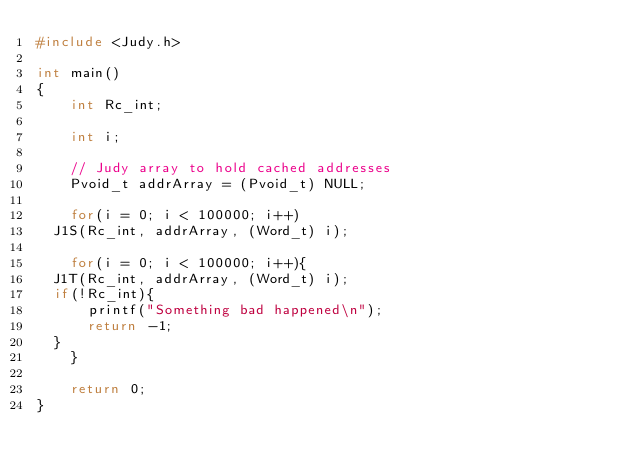<code> <loc_0><loc_0><loc_500><loc_500><_C_>#include <Judy.h>

int main()
{
    int Rc_int;

    int i;

    // Judy array to hold cached addresses
    Pvoid_t addrArray = (Pvoid_t) NULL;

    for(i = 0; i < 100000; i++)
	J1S(Rc_int, addrArray, (Word_t) i);

    for(i = 0; i < 100000; i++){
	J1T(Rc_int, addrArray, (Word_t) i);
	if(!Rc_int){
	    printf("Something bad happened\n");
	    return -1;
	}
    }

    return 0;
}
</code> 